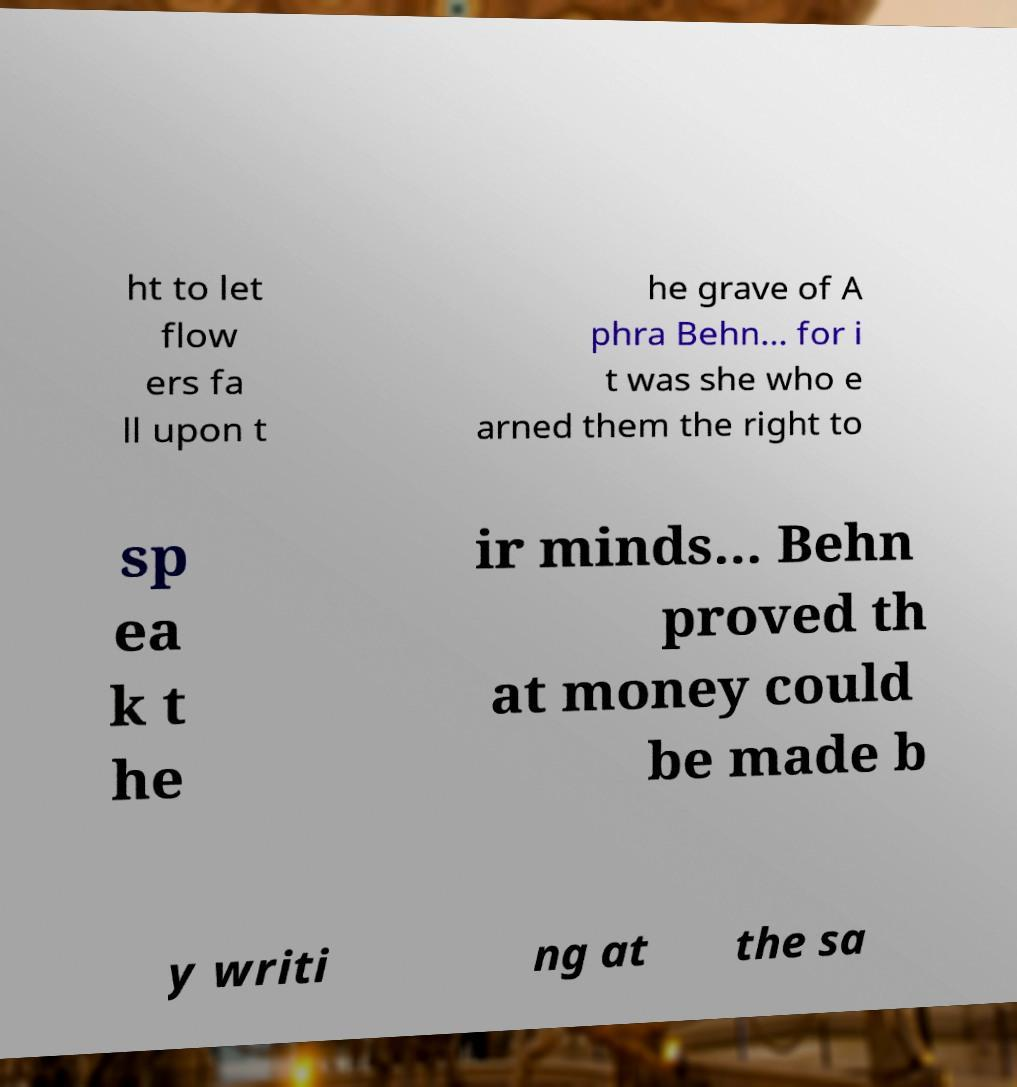There's text embedded in this image that I need extracted. Can you transcribe it verbatim? ht to let flow ers fa ll upon t he grave of A phra Behn... for i t was she who e arned them the right to sp ea k t he ir minds... Behn proved th at money could be made b y writi ng at the sa 